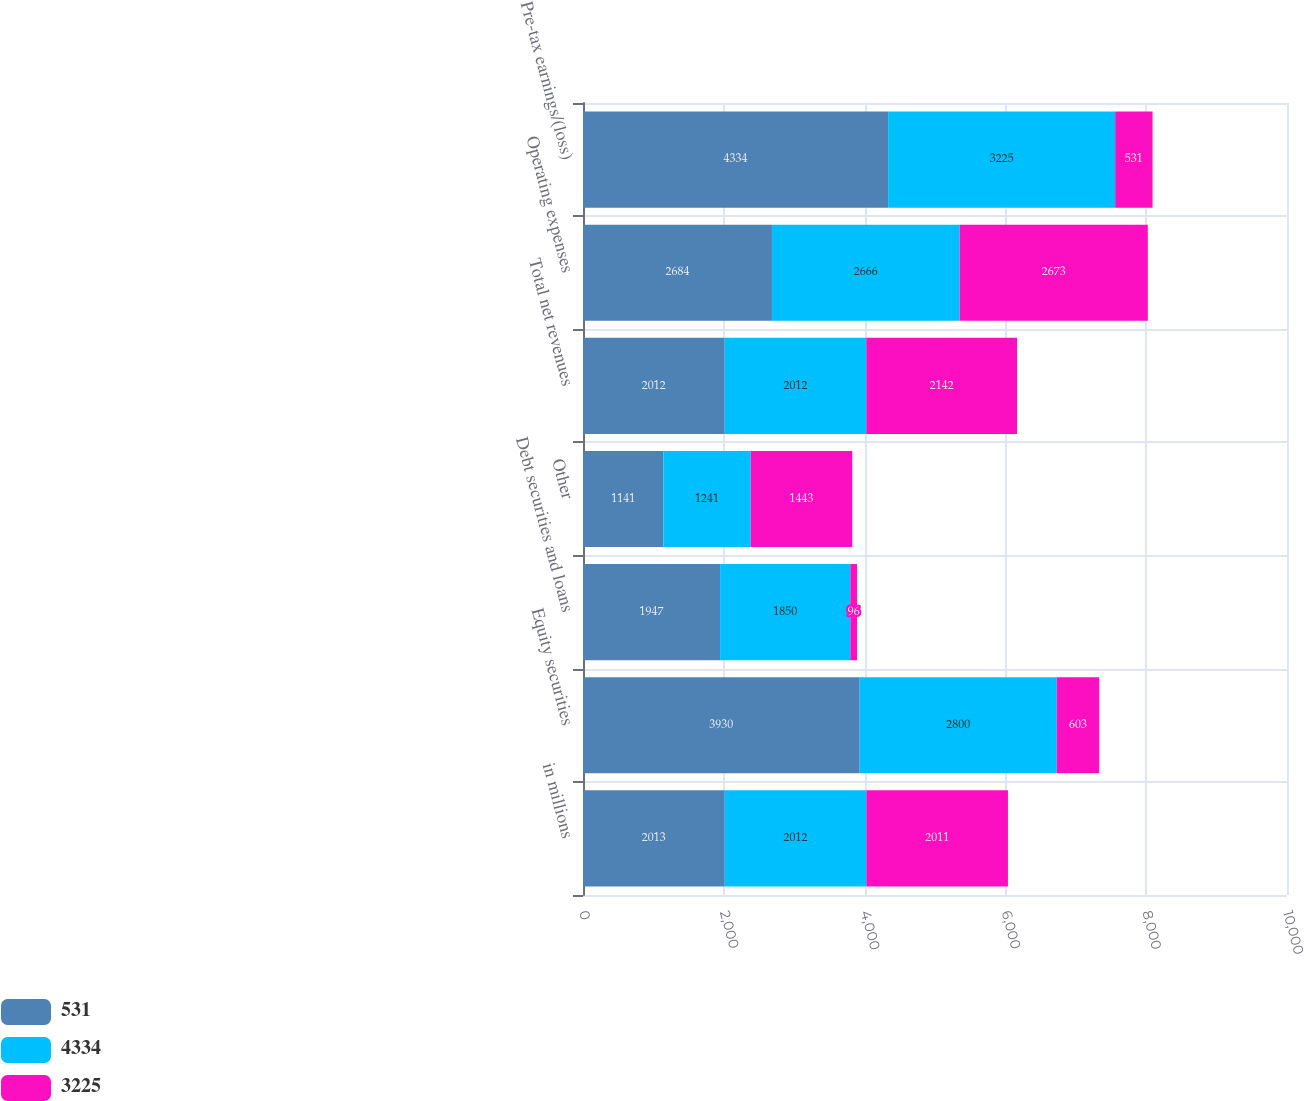<chart> <loc_0><loc_0><loc_500><loc_500><stacked_bar_chart><ecel><fcel>in millions<fcel>Equity securities<fcel>Debt securities and loans<fcel>Other<fcel>Total net revenues<fcel>Operating expenses<fcel>Pre-tax earnings/(loss)<nl><fcel>531<fcel>2013<fcel>3930<fcel>1947<fcel>1141<fcel>2012<fcel>2684<fcel>4334<nl><fcel>4334<fcel>2012<fcel>2800<fcel>1850<fcel>1241<fcel>2012<fcel>2666<fcel>3225<nl><fcel>3225<fcel>2011<fcel>603<fcel>96<fcel>1443<fcel>2142<fcel>2673<fcel>531<nl></chart> 